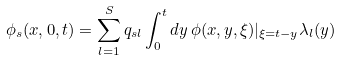Convert formula to latex. <formula><loc_0><loc_0><loc_500><loc_500>\phi _ { s } ( x , 0 , t ) = \sum _ { l = 1 } ^ { S } q _ { s l } \int _ { 0 } ^ { t } d y \, \phi ( x , y , \xi ) | _ { \xi = t - y } \lambda _ { l } ( y )</formula> 